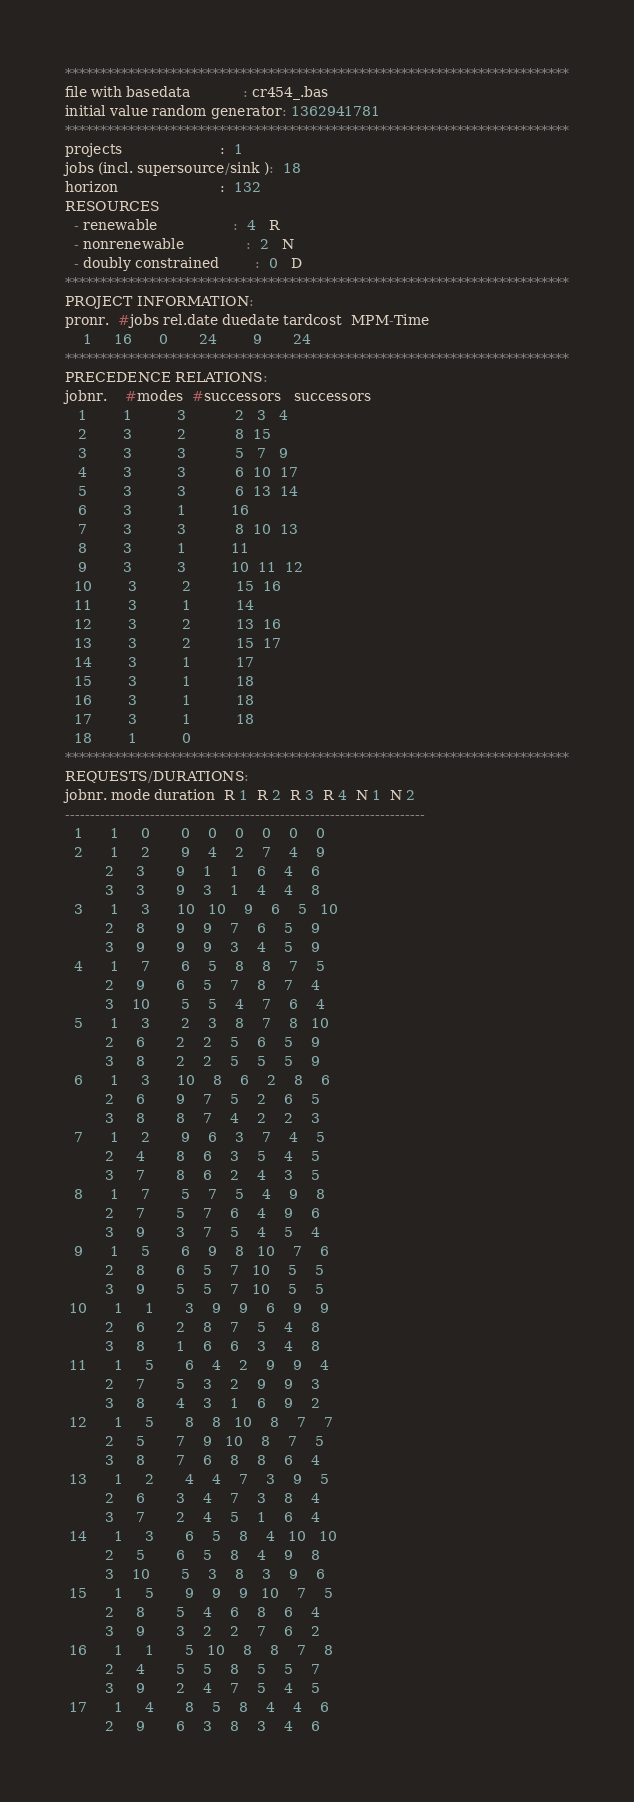Convert code to text. <code><loc_0><loc_0><loc_500><loc_500><_ObjectiveC_>************************************************************************
file with basedata            : cr454_.bas
initial value random generator: 1362941781
************************************************************************
projects                      :  1
jobs (incl. supersource/sink ):  18
horizon                       :  132
RESOURCES
  - renewable                 :  4   R
  - nonrenewable              :  2   N
  - doubly constrained        :  0   D
************************************************************************
PROJECT INFORMATION:
pronr.  #jobs rel.date duedate tardcost  MPM-Time
    1     16      0       24        9       24
************************************************************************
PRECEDENCE RELATIONS:
jobnr.    #modes  #successors   successors
   1        1          3           2   3   4
   2        3          2           8  15
   3        3          3           5   7   9
   4        3          3           6  10  17
   5        3          3           6  13  14
   6        3          1          16
   7        3          3           8  10  13
   8        3          1          11
   9        3          3          10  11  12
  10        3          2          15  16
  11        3          1          14
  12        3          2          13  16
  13        3          2          15  17
  14        3          1          17
  15        3          1          18
  16        3          1          18
  17        3          1          18
  18        1          0        
************************************************************************
REQUESTS/DURATIONS:
jobnr. mode duration  R 1  R 2  R 3  R 4  N 1  N 2
------------------------------------------------------------------------
  1      1     0       0    0    0    0    0    0
  2      1     2       9    4    2    7    4    9
         2     3       9    1    1    6    4    6
         3     3       9    3    1    4    4    8
  3      1     3      10   10    9    6    5   10
         2     8       9    9    7    6    5    9
         3     9       9    9    3    4    5    9
  4      1     7       6    5    8    8    7    5
         2     9       6    5    7    8    7    4
         3    10       5    5    4    7    6    4
  5      1     3       2    3    8    7    8   10
         2     6       2    2    5    6    5    9
         3     8       2    2    5    5    5    9
  6      1     3      10    8    6    2    8    6
         2     6       9    7    5    2    6    5
         3     8       8    7    4    2    2    3
  7      1     2       9    6    3    7    4    5
         2     4       8    6    3    5    4    5
         3     7       8    6    2    4    3    5
  8      1     7       5    7    5    4    9    8
         2     7       5    7    6    4    9    6
         3     9       3    7    5    4    5    4
  9      1     5       6    9    8   10    7    6
         2     8       6    5    7   10    5    5
         3     9       5    5    7   10    5    5
 10      1     1       3    9    9    6    9    9
         2     6       2    8    7    5    4    8
         3     8       1    6    6    3    4    8
 11      1     5       6    4    2    9    9    4
         2     7       5    3    2    9    9    3
         3     8       4    3    1    6    9    2
 12      1     5       8    8   10    8    7    7
         2     5       7    9   10    8    7    5
         3     8       7    6    8    8    6    4
 13      1     2       4    4    7    3    9    5
         2     6       3    4    7    3    8    4
         3     7       2    4    5    1    6    4
 14      1     3       6    5    8    4   10   10
         2     5       6    5    8    4    9    8
         3    10       5    3    8    3    9    6
 15      1     5       9    9    9   10    7    5
         2     8       5    4    6    8    6    4
         3     9       3    2    2    7    6    2
 16      1     1       5   10    8    8    7    8
         2     4       5    5    8    5    5    7
         3     9       2    4    7    5    4    5
 17      1     4       8    5    8    4    4    6
         2     9       6    3    8    3    4    6</code> 